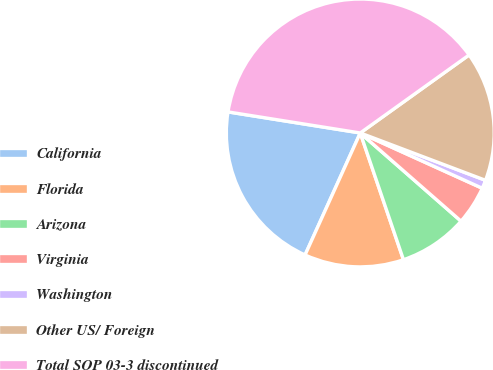Convert chart. <chart><loc_0><loc_0><loc_500><loc_500><pie_chart><fcel>California<fcel>Florida<fcel>Arizona<fcel>Virginia<fcel>Washington<fcel>Other US/ Foreign<fcel>Total SOP 03-3 discontinued<nl><fcel>20.75%<fcel>11.99%<fcel>8.33%<fcel>4.67%<fcel>1.02%<fcel>15.65%<fcel>37.59%<nl></chart> 